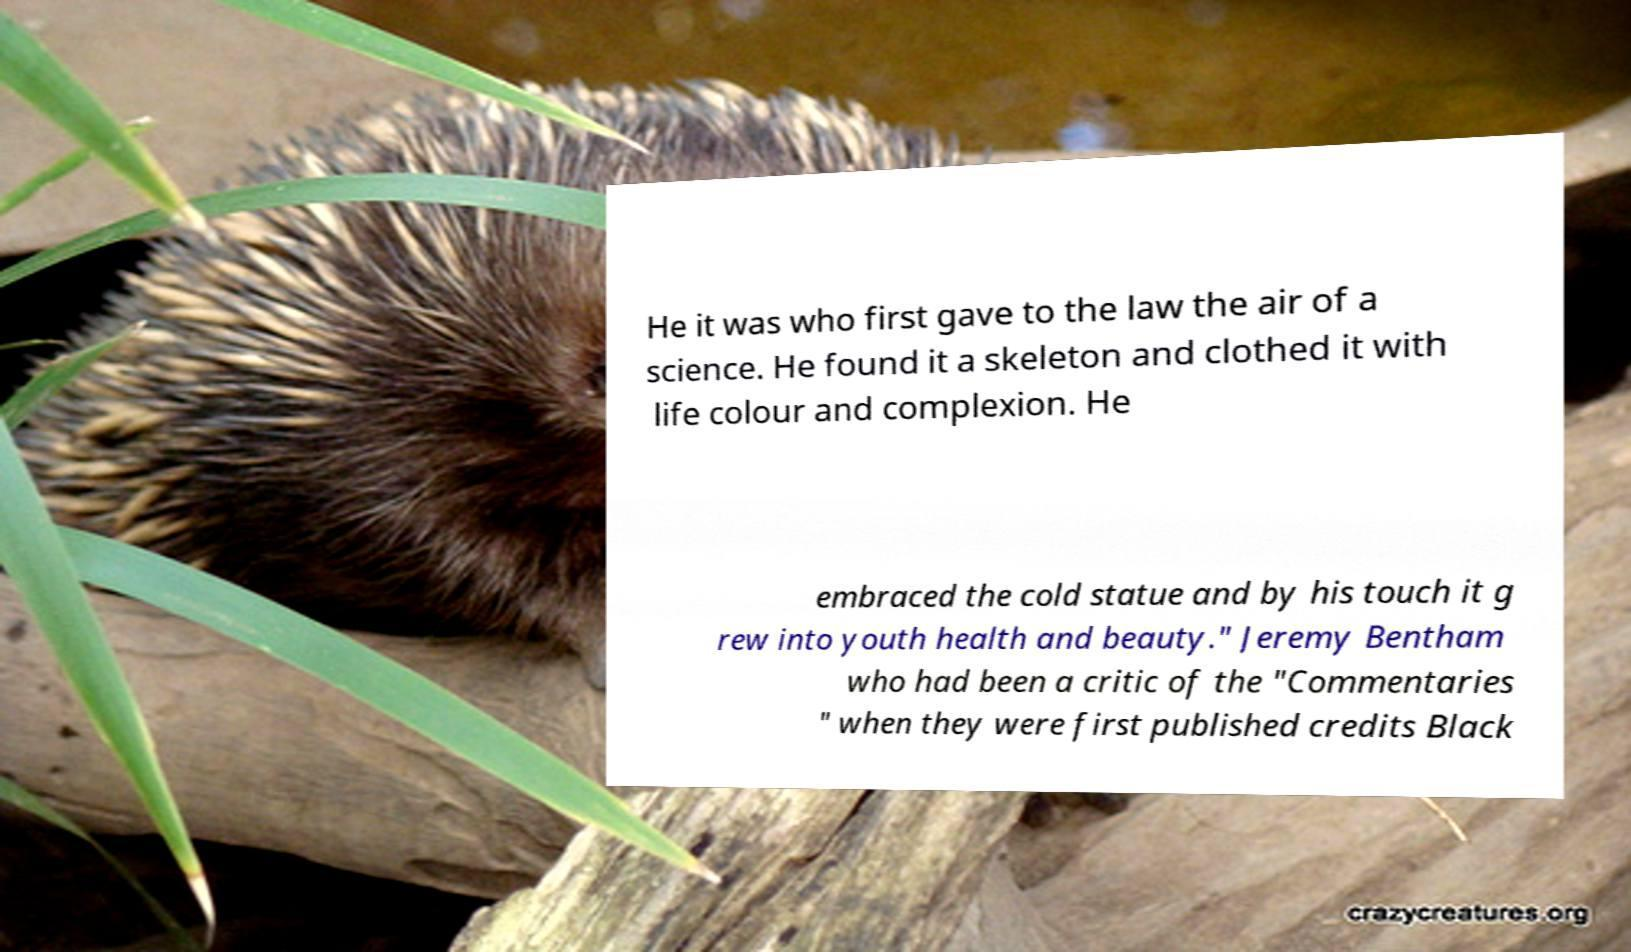For documentation purposes, I need the text within this image transcribed. Could you provide that? He it was who first gave to the law the air of a science. He found it a skeleton and clothed it with life colour and complexion. He embraced the cold statue and by his touch it g rew into youth health and beauty." Jeremy Bentham who had been a critic of the "Commentaries " when they were first published credits Black 